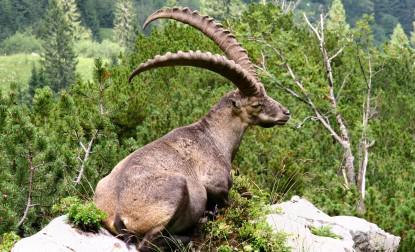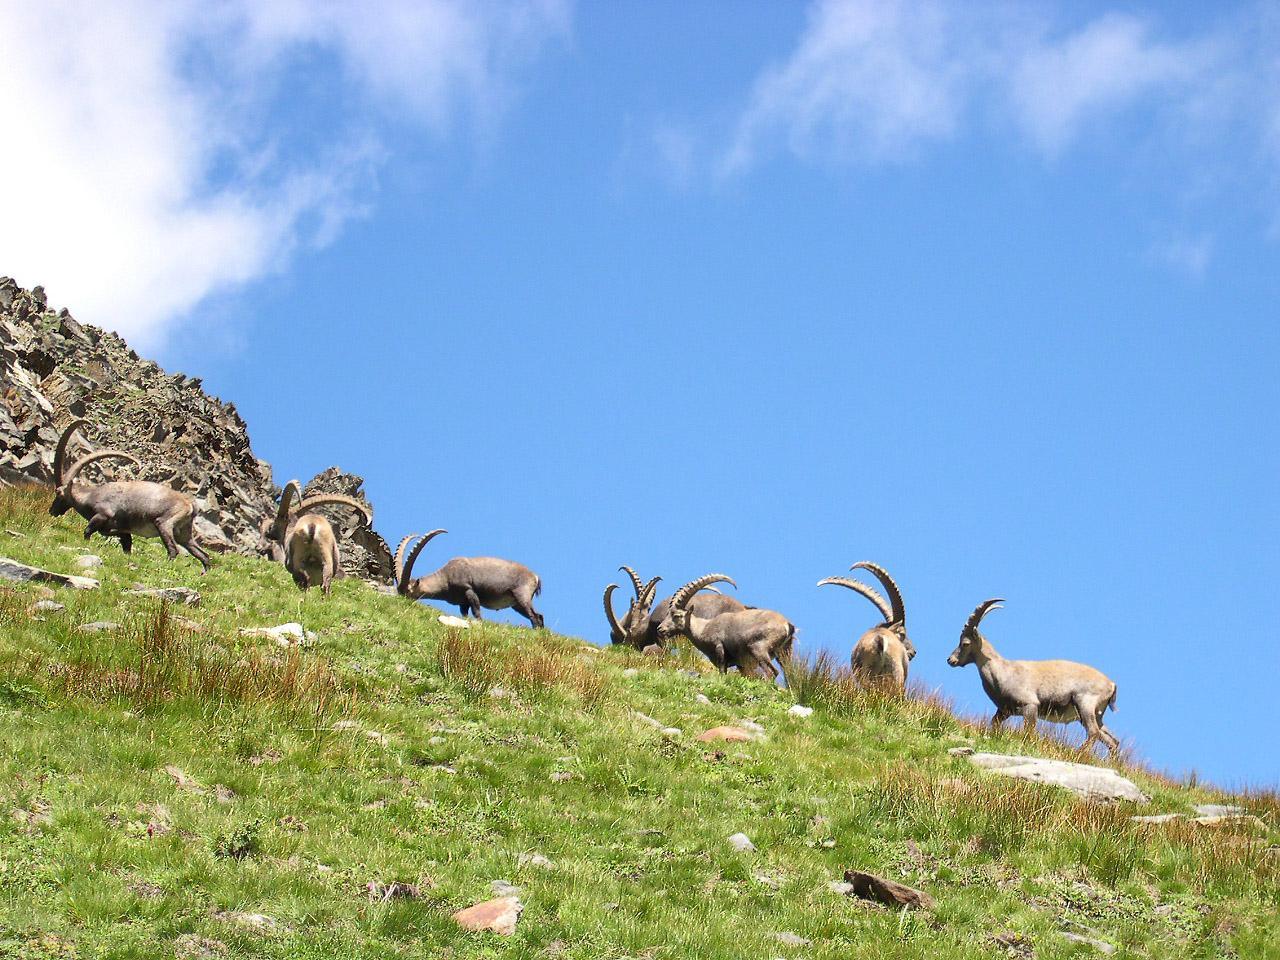The first image is the image on the left, the second image is the image on the right. Assess this claim about the two images: "An image shows a single horned animal in a non-standing position.". Correct or not? Answer yes or no. Yes. 